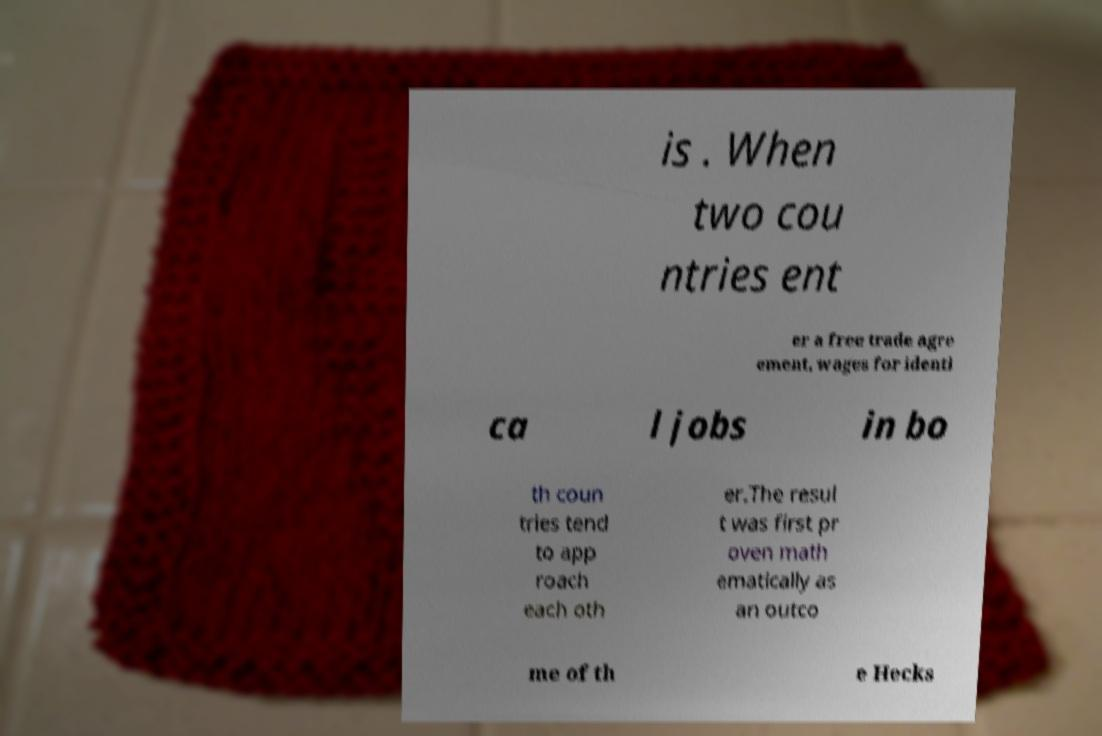Can you accurately transcribe the text from the provided image for me? is . When two cou ntries ent er a free trade agre ement, wages for identi ca l jobs in bo th coun tries tend to app roach each oth er.The resul t was first pr oven math ematically as an outco me of th e Hecks 